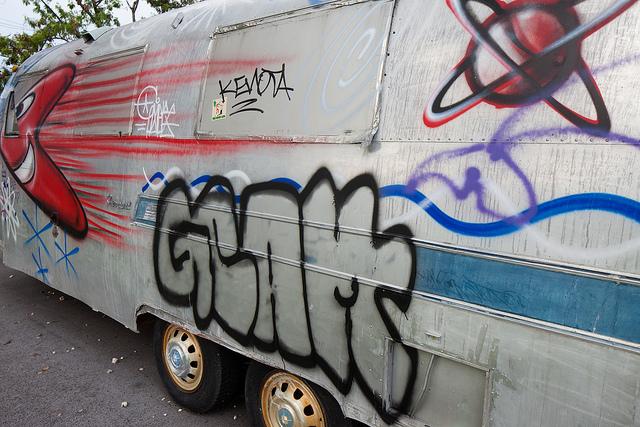How many wheels does the vehicle have?
Answer briefly. 2. Is this vehicle covered up in graffiti?
Answer briefly. Yes. What was used to create the graffiti?
Be succinct. Spray paint. 